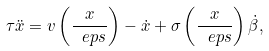<formula> <loc_0><loc_0><loc_500><loc_500>\tau \ddot { x } = v \left ( \frac { x } { \ e p s } \right ) - \dot { x } + \sigma \left ( \frac { x } { \ e p s } \right ) \dot { \beta } ,</formula> 